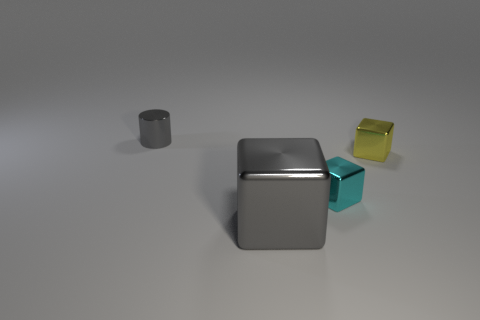How big is the gray object that is behind the gray metallic thing in front of the thing that is behind the yellow shiny cube? The gray object behind the gray metallic cube and in front of what is behind the yellow cube appears to be a small cylindrical shape, roughly one-third the height of the yellow cube and significantly smaller in diameter than the gray metallic cube. 